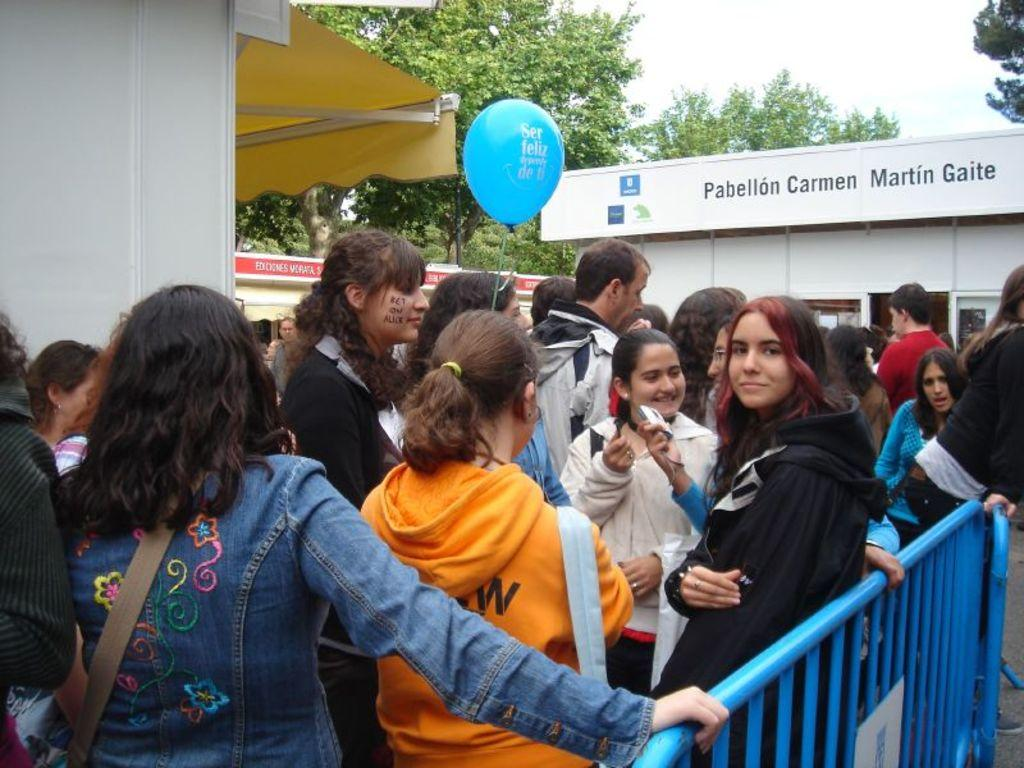What can be seen in the foreground of the image? There are people standing in the foreground of the image. What are some people wearing in the image? Some people are wearing bags in the image. What is a person holding in the image? A person is holding a balloon in the image. What can be seen in the background of the image? There are buildings, trees, and the sky visible in the background of the image. What is the price of the attraction in the image? There is no attraction present in the image, so it is not possible to determine its price. 